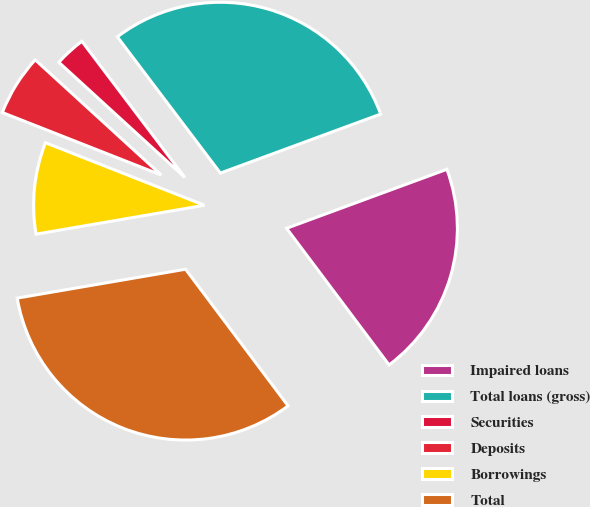<chart> <loc_0><loc_0><loc_500><loc_500><pie_chart><fcel>Impaired loans<fcel>Total loans (gross)<fcel>Securities<fcel>Deposits<fcel>Borrowings<fcel>Total<nl><fcel>20.37%<fcel>29.69%<fcel>2.91%<fcel>5.82%<fcel>8.67%<fcel>32.54%<nl></chart> 